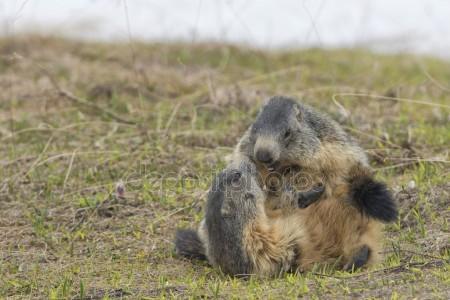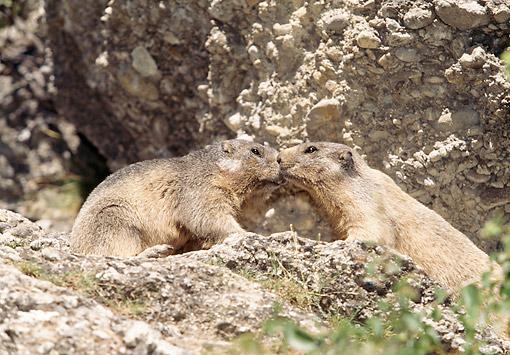The first image is the image on the left, the second image is the image on the right. Examine the images to the left and right. Is the description "Right image shows two marmots on all fours posed face-to-face." accurate? Answer yes or no. Yes. The first image is the image on the left, the second image is the image on the right. Analyze the images presented: Is the assertion "Two animals are interacting in a field in both images." valid? Answer yes or no. No. 